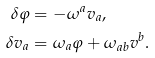<formula> <loc_0><loc_0><loc_500><loc_500>\delta \varphi & = - \omega ^ { a } v _ { a } , \\ \delta v _ { a } & = \omega _ { a } \varphi + \omega _ { a b } v ^ { b } .</formula> 